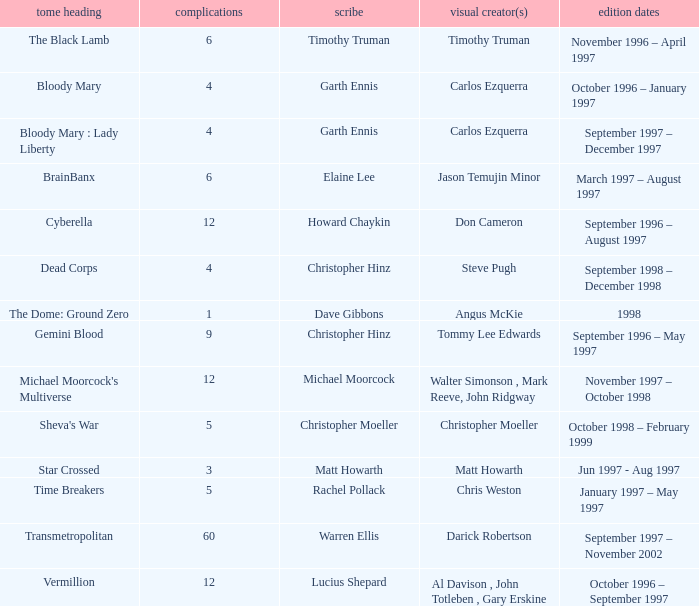What artist has a book called cyberella Don Cameron. 